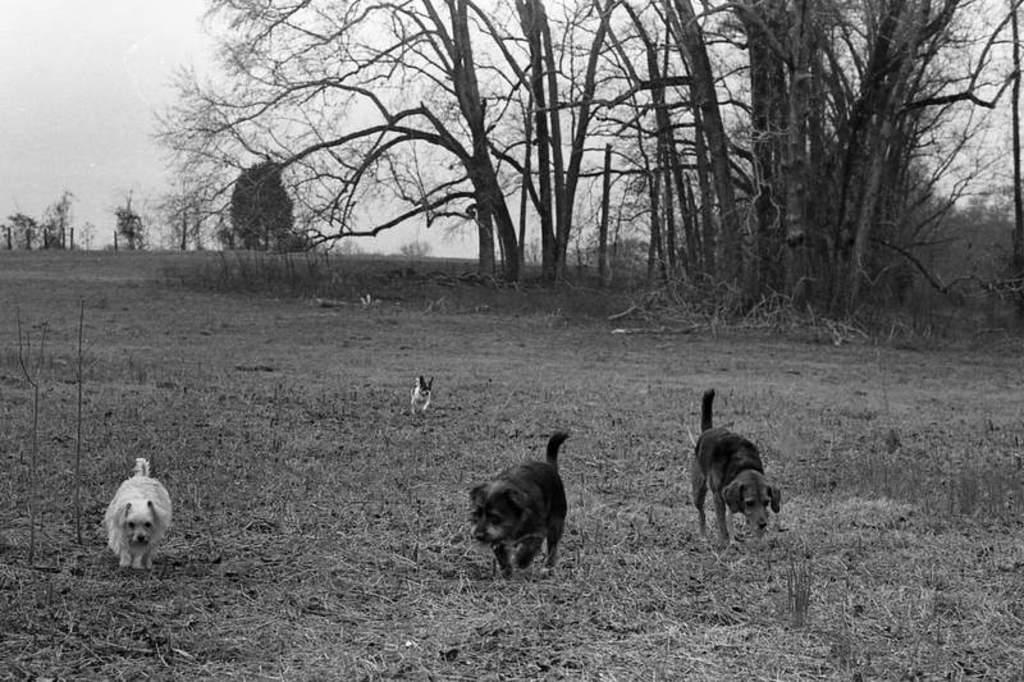What type of photography is depicted in the image? The image contains a black and white photography. What subject matter is featured in the photography? The photography features dogs. Where are the dogs located in the image? The dogs are on the ground. What can be seen in the background of the image? There are dry trees in the background of the image. What type of apparatus is being used by the dogs to help them sleep in the image? There is no apparatus or indication of the dogs sleeping in the image; they are simply on the ground. 